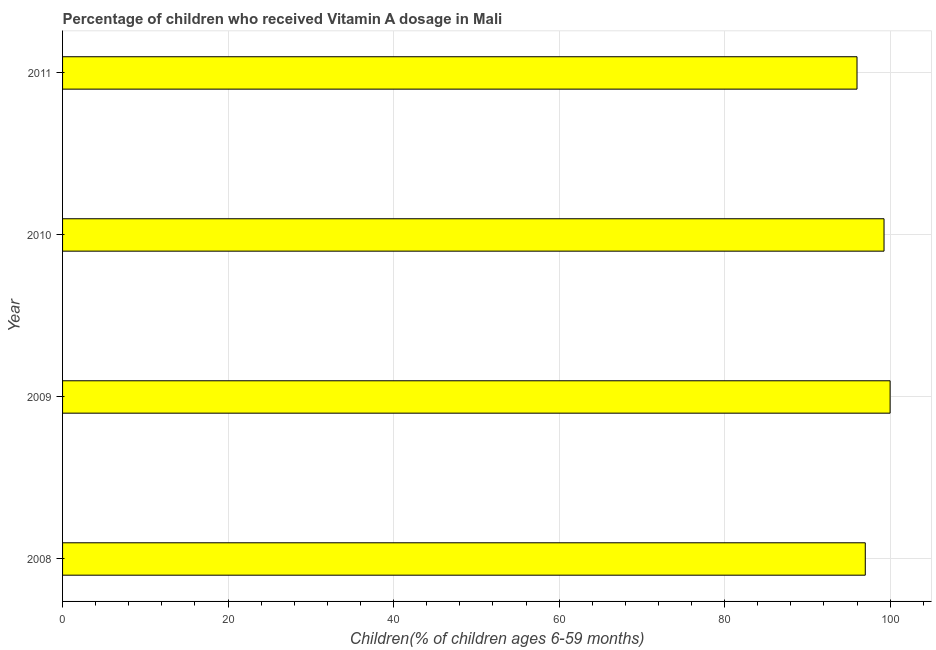What is the title of the graph?
Your answer should be very brief. Percentage of children who received Vitamin A dosage in Mali. What is the label or title of the X-axis?
Ensure brevity in your answer.  Children(% of children ages 6-59 months). What is the vitamin a supplementation coverage rate in 2010?
Your response must be concise. 99.26. Across all years, what is the minimum vitamin a supplementation coverage rate?
Offer a very short reply. 96. What is the sum of the vitamin a supplementation coverage rate?
Your answer should be compact. 392.26. What is the average vitamin a supplementation coverage rate per year?
Make the answer very short. 98.07. What is the median vitamin a supplementation coverage rate?
Provide a short and direct response. 98.13. In how many years, is the vitamin a supplementation coverage rate greater than 52 %?
Your answer should be very brief. 4. Do a majority of the years between 2009 and 2011 (inclusive) have vitamin a supplementation coverage rate greater than 76 %?
Make the answer very short. Yes. Is the vitamin a supplementation coverage rate in 2009 less than that in 2010?
Offer a terse response. No. What is the difference between the highest and the second highest vitamin a supplementation coverage rate?
Keep it short and to the point. 0.74. What is the difference between the highest and the lowest vitamin a supplementation coverage rate?
Your answer should be compact. 4. In how many years, is the vitamin a supplementation coverage rate greater than the average vitamin a supplementation coverage rate taken over all years?
Your answer should be compact. 2. How many bars are there?
Provide a succinct answer. 4. Are all the bars in the graph horizontal?
Offer a terse response. Yes. How many years are there in the graph?
Give a very brief answer. 4. What is the difference between two consecutive major ticks on the X-axis?
Ensure brevity in your answer.  20. What is the Children(% of children ages 6-59 months) in 2008?
Keep it short and to the point. 97. What is the Children(% of children ages 6-59 months) of 2009?
Your answer should be very brief. 100. What is the Children(% of children ages 6-59 months) of 2010?
Offer a terse response. 99.26. What is the Children(% of children ages 6-59 months) in 2011?
Offer a terse response. 96. What is the difference between the Children(% of children ages 6-59 months) in 2008 and 2010?
Your response must be concise. -2.26. What is the difference between the Children(% of children ages 6-59 months) in 2009 and 2010?
Ensure brevity in your answer.  0.74. What is the difference between the Children(% of children ages 6-59 months) in 2010 and 2011?
Your response must be concise. 3.26. What is the ratio of the Children(% of children ages 6-59 months) in 2008 to that in 2010?
Offer a very short reply. 0.98. What is the ratio of the Children(% of children ages 6-59 months) in 2009 to that in 2011?
Make the answer very short. 1.04. What is the ratio of the Children(% of children ages 6-59 months) in 2010 to that in 2011?
Your answer should be very brief. 1.03. 